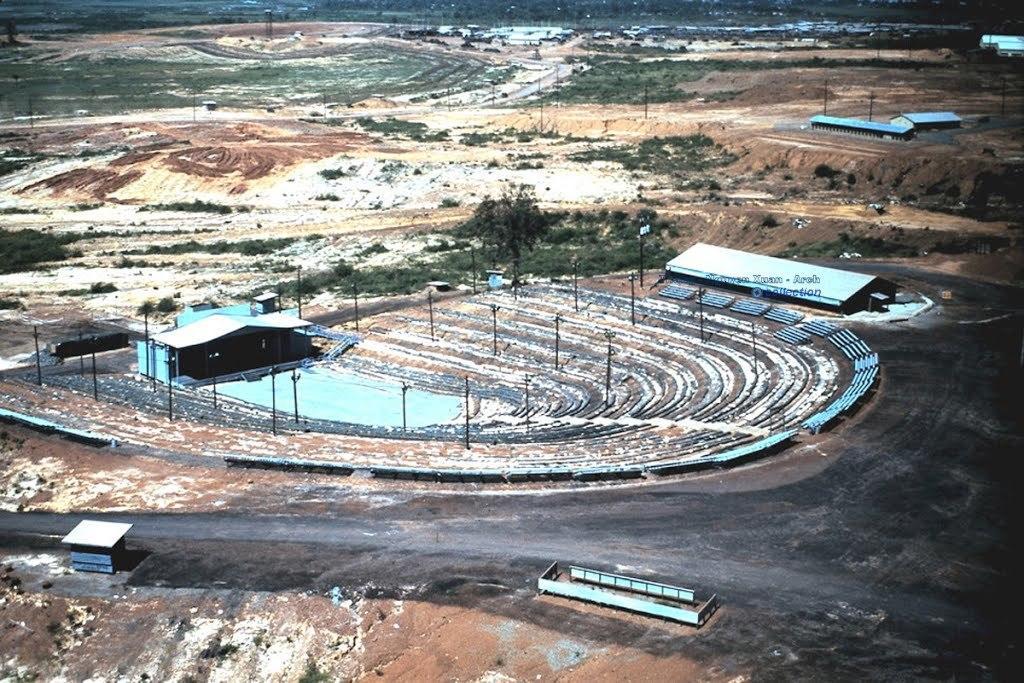How would you summarize this image in a sentence or two? In this image we can see houses, poles, objects are on the ground. In the background we can see grass and poles on the ground. 